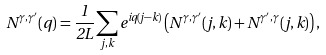Convert formula to latex. <formula><loc_0><loc_0><loc_500><loc_500>N ^ { \gamma , \gamma ^ { \prime } } ( q ) = \frac { 1 } { 2 L } \sum _ { j , k } e ^ { i q ( j - k ) } \left ( N ^ { \gamma , \gamma ^ { \prime } } ( j , k ) + N ^ { \gamma ^ { \prime } , \gamma } ( j , k ) \right ) ,</formula> 